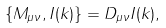<formula> <loc_0><loc_0><loc_500><loc_500>\{ M _ { \mu \nu } , I ( k ) \} = D _ { \mu \nu } I ( k ) ,</formula> 